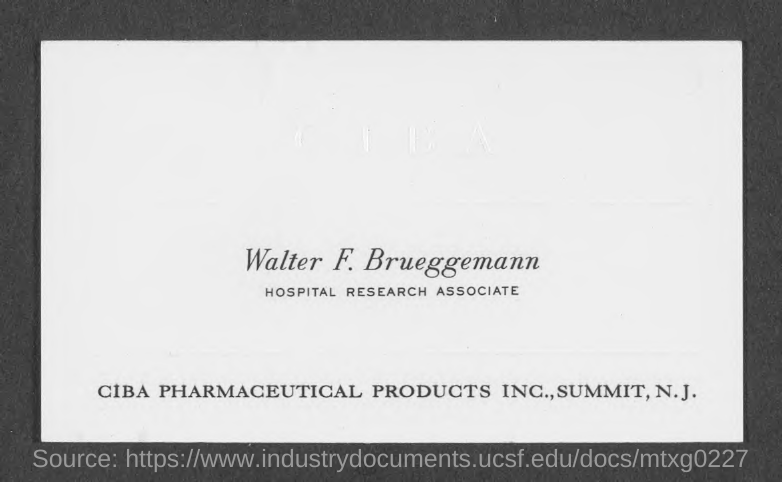What is the designation of walter f. brueggemann?
Keep it short and to the point. Hospital Research Associate. 